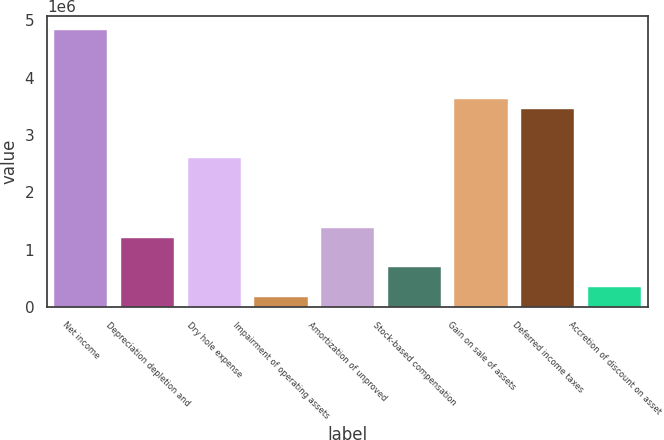Convert chart. <chart><loc_0><loc_0><loc_500><loc_500><bar_chart><fcel>Net income<fcel>Depreciation depletion and<fcel>Dry hole expense<fcel>Impairment of operating assets<fcel>Amortization of unproved<fcel>Stock-based compensation<fcel>Gain on sale of assets<fcel>Deferred income taxes<fcel>Accretion of discount on asset<nl><fcel>4.83594e+06<fcel>1.2127e+06<fcel>2.59298e+06<fcel>177489<fcel>1.38524e+06<fcel>695095<fcel>3.62819e+06<fcel>3.45566e+06<fcel>350024<nl></chart> 